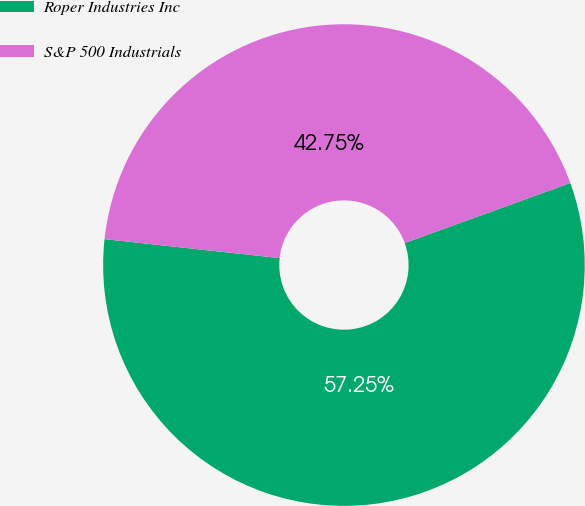Convert chart to OTSL. <chart><loc_0><loc_0><loc_500><loc_500><pie_chart><fcel>Roper Industries Inc<fcel>S&P 500 Industrials<nl><fcel>57.25%<fcel>42.75%<nl></chart> 